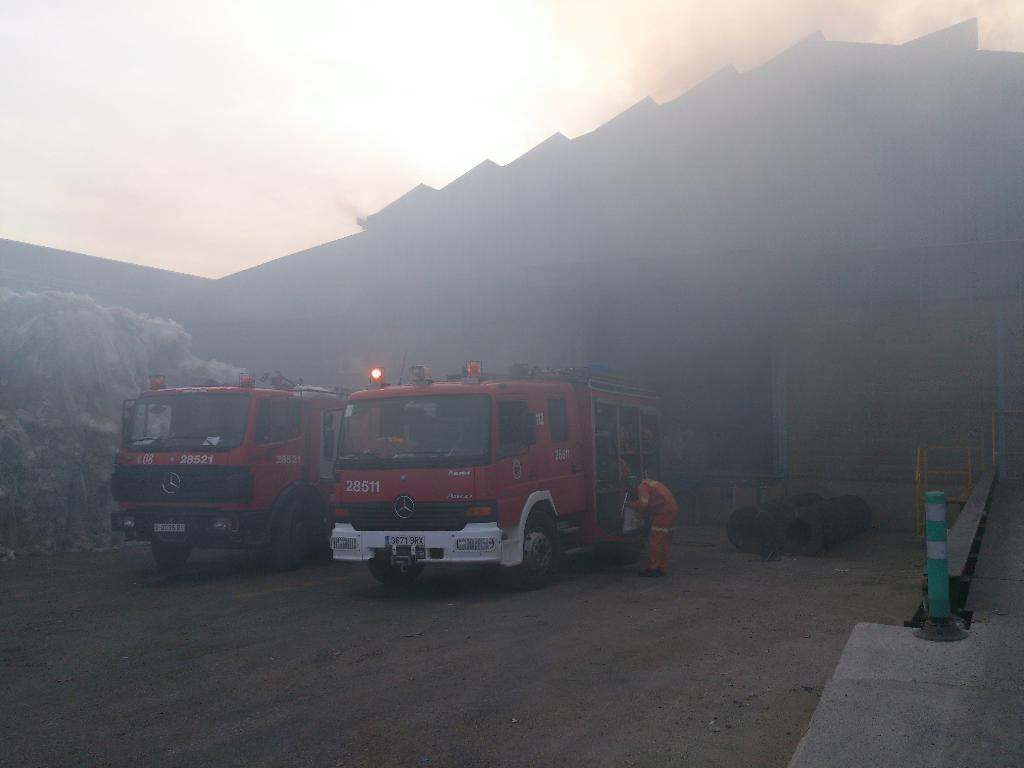What color are the vehicles in the image? The vehicles in the image are red. Can you describe any other subjects or objects in the image? Yes, there is a person and a traffic pole on the right side of the image. What can be seen in the background of the image? Smoke is visible in the background of the image, and the background appears blurry. What type of cake is being served to the person in the image? There is no cake present in the image; it features red vehicles, a person, a traffic pole, smoke, and a blurry background. 